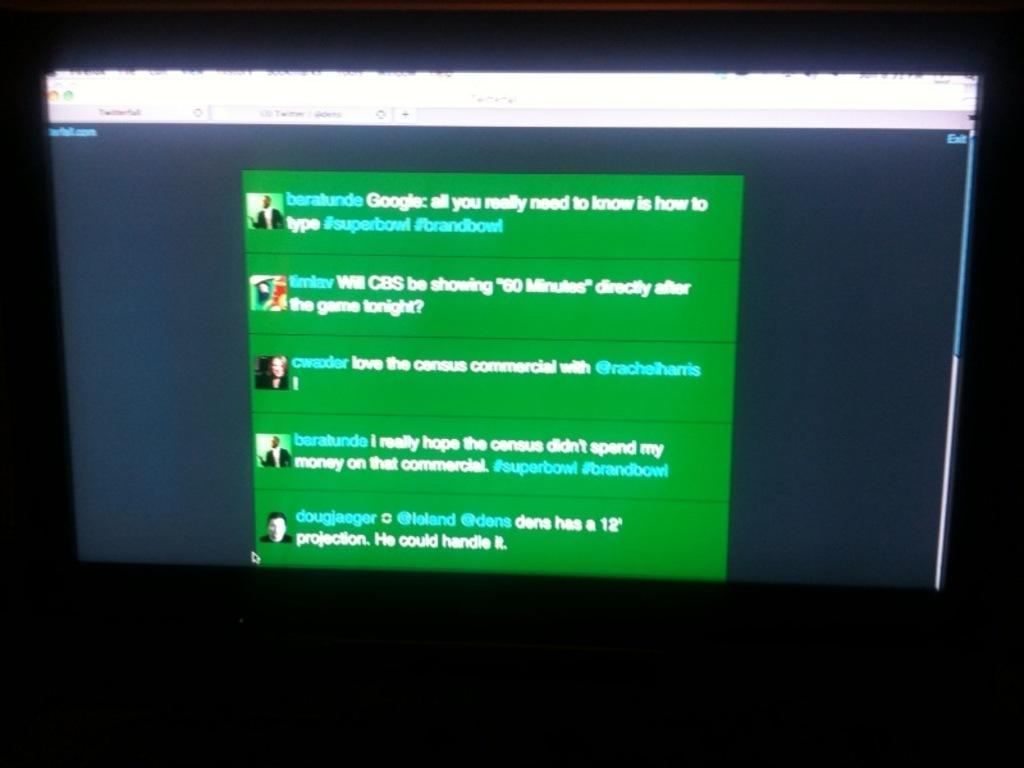<image>
Render a clear and concise summary of the photo. A conversation is occurring that addresses commercials on a television program. 